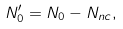Convert formula to latex. <formula><loc_0><loc_0><loc_500><loc_500>N ^ { \prime } _ { 0 } = N _ { 0 } - N _ { n c } ,</formula> 